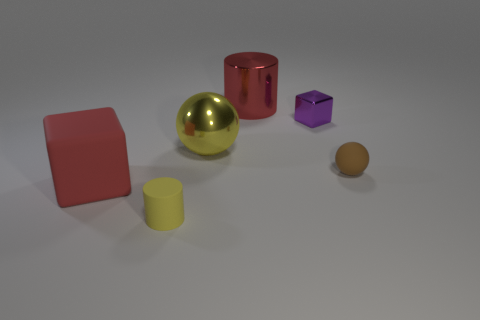Add 1 small red cylinders. How many objects exist? 7 Subtract all cylinders. How many objects are left? 4 Add 3 big matte cubes. How many big matte cubes exist? 4 Subtract 1 purple blocks. How many objects are left? 5 Subtract all green cylinders. Subtract all large red matte things. How many objects are left? 5 Add 4 purple things. How many purple things are left? 5 